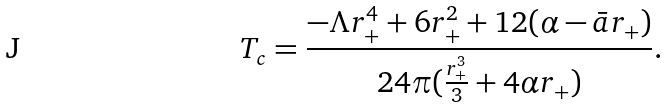Convert formula to latex. <formula><loc_0><loc_0><loc_500><loc_500>T _ { c } = \frac { - \Lambda r _ { + } ^ { 4 } + 6 r _ { + } ^ { 2 } + 1 2 ( \alpha - \bar { a } r _ { + } ) } { 2 4 \pi ( \frac { r _ { + } ^ { 3 } } { 3 } + 4 \alpha r _ { + } ) } .</formula> 